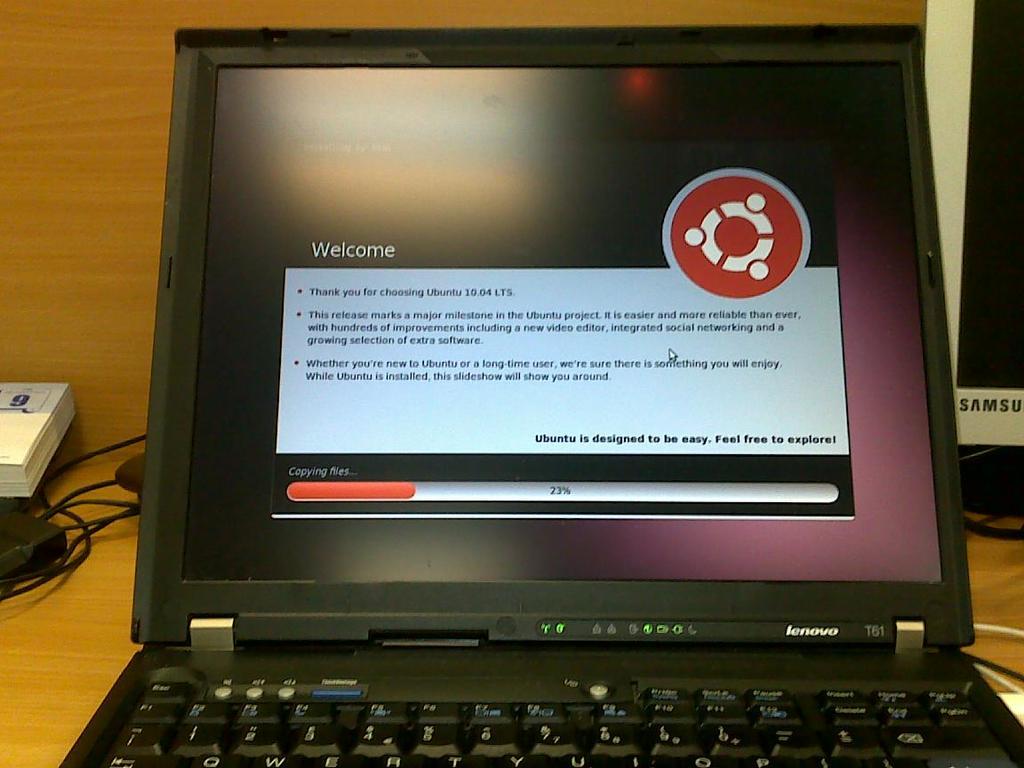What brand of computer is that?
Provide a succinct answer. Lenovo. What percent of the files are currently copied?
Offer a terse response. 23. 